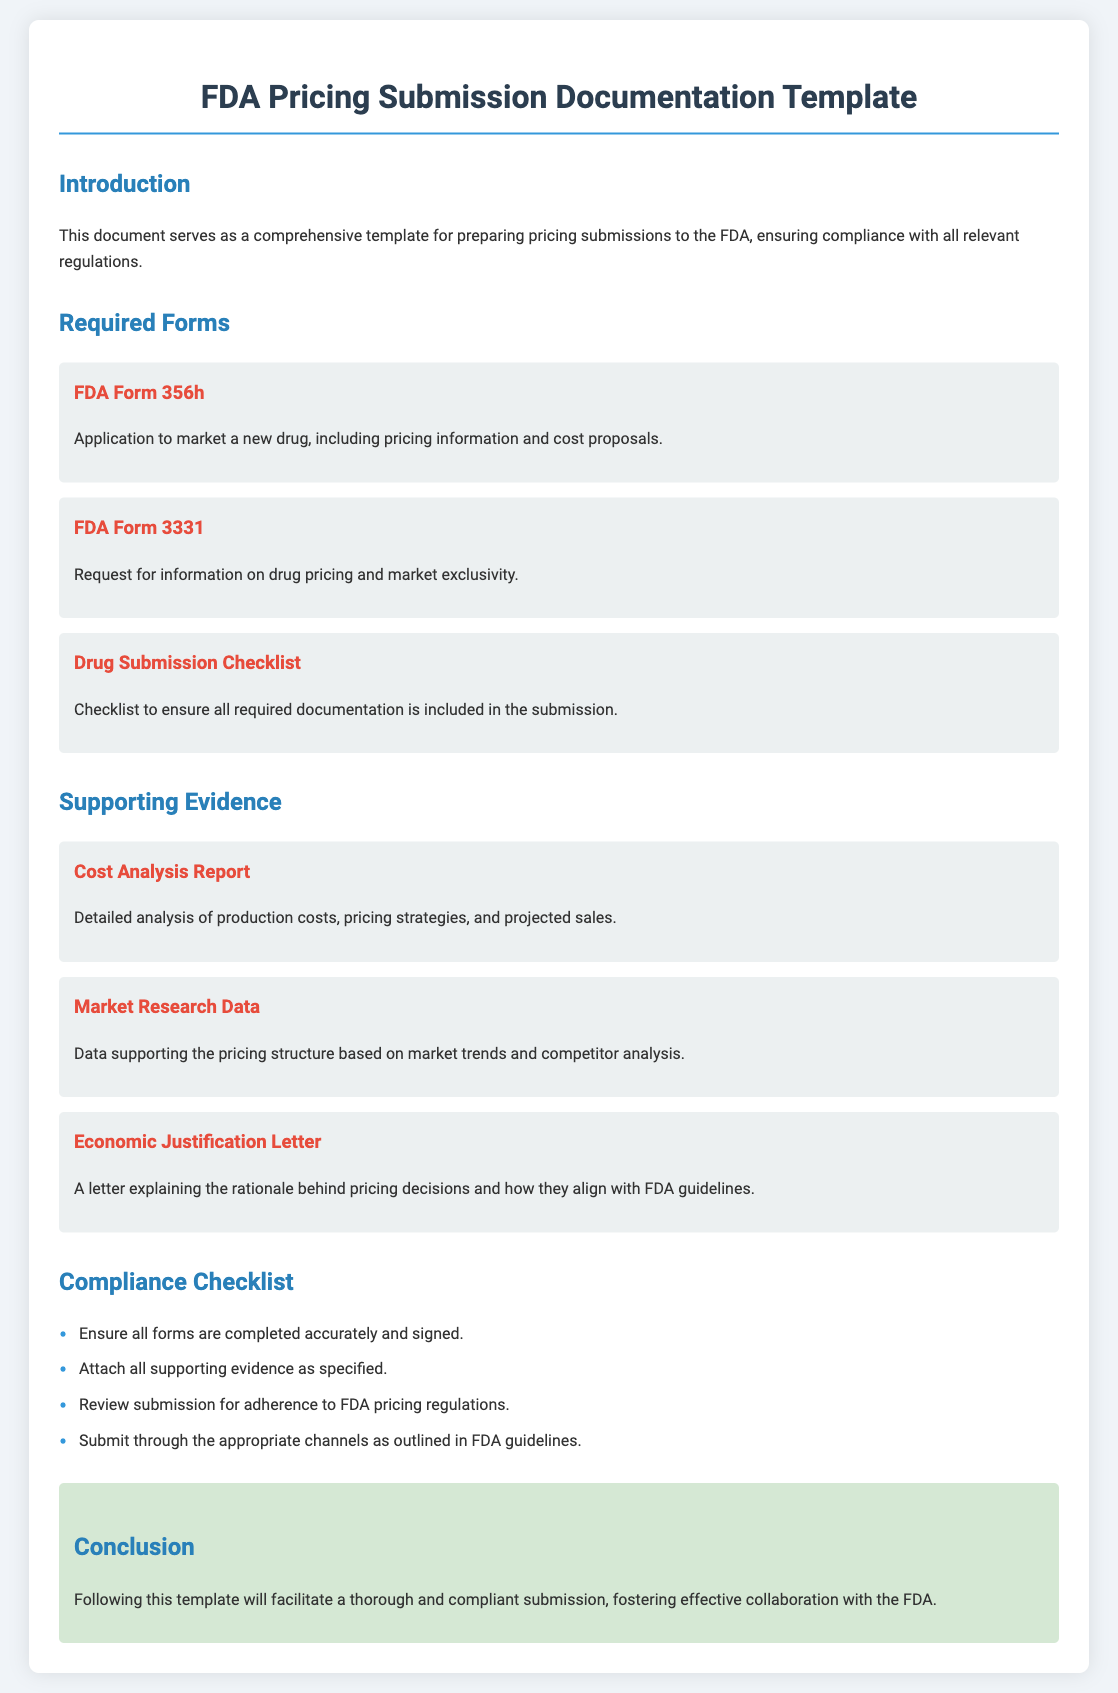What is the title of the document? The title is indicated at the top of the document and describes its purpose.
Answer: FDA Pricing Submission Documentation Template What is FDA Form 356h used for? The document specifies the use of FDA Form 356h within the "Required Forms" section.
Answer: Application to market a new drug, including pricing information and cost proposals What document is required for drug pricing and market exclusivity? This information is found in the "Required Forms" section of the document.
Answer: FDA Form 3331 How many forms are listed under "Required Forms"? The total can be deduced from counting the entries in the "Required Forms" section.
Answer: Three What is included in the "Supporting Evidence"? The "Supporting Evidence" section contains specific items related to pricing justifications.
Answer: Cost Analysis Report, Market Research Data, Economic Justification Letter What is one element listed in the Compliance Checklist? The checklist elements help ensure adherence to submission guidelines.
Answer: Ensure all forms are completed accurately and signed What does the conclusion encourage? The conclusion summarizes the document's main aim and provides guidance.
Answer: A thorough and compliant submission How many sections are in the document? The sections can be counted in the outlined structure of the document.
Answer: Four 